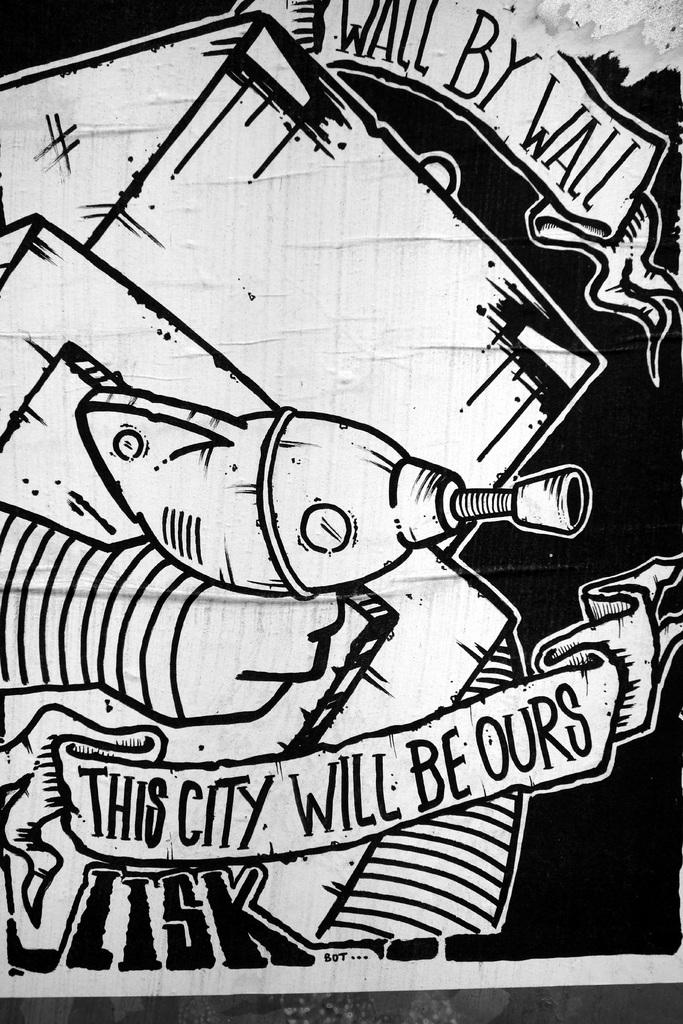What is the main subject of the image? The main subject of the image is a sketch. Can you describe the sketch in more detail? Yes, there is text written in the sketch. What type of door can be seen in the sketch? There is no door present in the sketch; it only contains text. Is the text written with a metal pen in the sketch? The type of writing instrument used is not mentioned in the facts, so we cannot determine if it was a metal pen or not. 